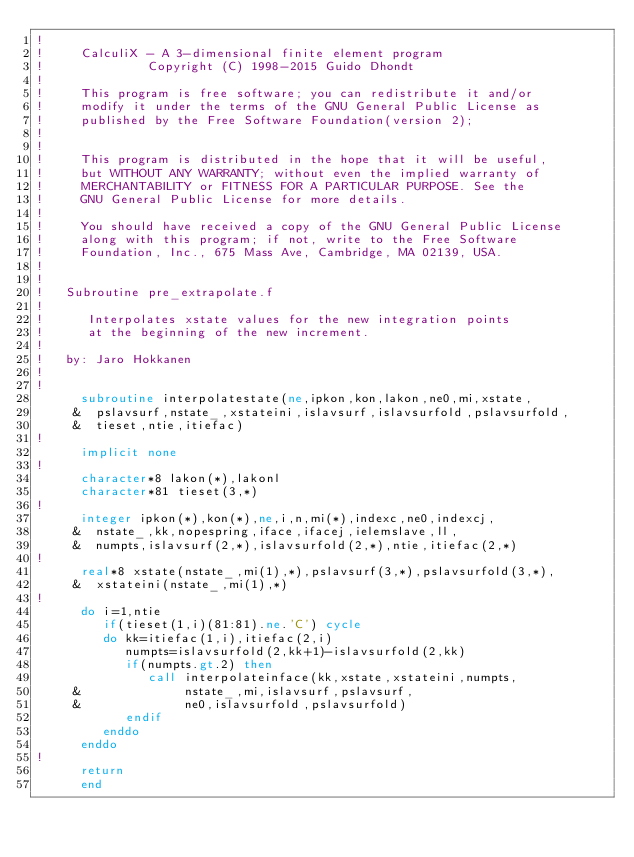Convert code to text. <code><loc_0><loc_0><loc_500><loc_500><_FORTRAN_>!
!     CalculiX - A 3-dimensional finite element program
!              Copyright (C) 1998-2015 Guido Dhondt
!
!     This program is free software; you can redistribute it and/or
!     modify it under the terms of the GNU General Public License as
!     published by the Free Software Foundation(version 2);
!     
!
!     This program is distributed in the hope that it will be useful,
!     but WITHOUT ANY WARRANTY; without even the implied warranty of 
!     MERCHANTABILITY or FITNESS FOR A PARTICULAR PURPOSE. See the 
!     GNU General Public License for more details.
!
!     You should have received a copy of the GNU General Public License
!     along with this program; if not, write to the Free Software
!     Foundation, Inc., 675 Mass Ave, Cambridge, MA 02139, USA.
!
!
!   Subroutine pre_extrapolate.f
!
!      Interpolates xstate values for the new integration points 
!      at the beginning of the new increment. 
!
!   by: Jaro Hokkanen
!
!
      subroutine interpolatestate(ne,ipkon,kon,lakon,ne0,mi,xstate,
     &  pslavsurf,nstate_,xstateini,islavsurf,islavsurfold,pslavsurfold,
     &  tieset,ntie,itiefac)
!
      implicit none
!
      character*8 lakon(*),lakonl
      character*81 tieset(3,*)
!
      integer ipkon(*),kon(*),ne,i,n,mi(*),indexc,ne0,indexcj,
     &  nstate_,kk,nopespring,iface,ifacej,ielemslave,ll,
     &  numpts,islavsurf(2,*),islavsurfold(2,*),ntie,itiefac(2,*)
!
      real*8 xstate(nstate_,mi(1),*),pslavsurf(3,*),pslavsurfold(3,*),
     &  xstateini(nstate_,mi(1),*)
!
      do i=1,ntie
         if(tieset(1,i)(81:81).ne.'C') cycle
         do kk=itiefac(1,i),itiefac(2,i)
            numpts=islavsurfold(2,kk+1)-islavsurfold(2,kk)
            if(numpts.gt.2) then
               call interpolateinface(kk,xstate,xstateini,numpts,
     &              nstate_,mi,islavsurf,pslavsurf,
     &              ne0,islavsurfold,pslavsurfold)
            endif
         enddo
      enddo
!     
      return
      end
      
</code> 